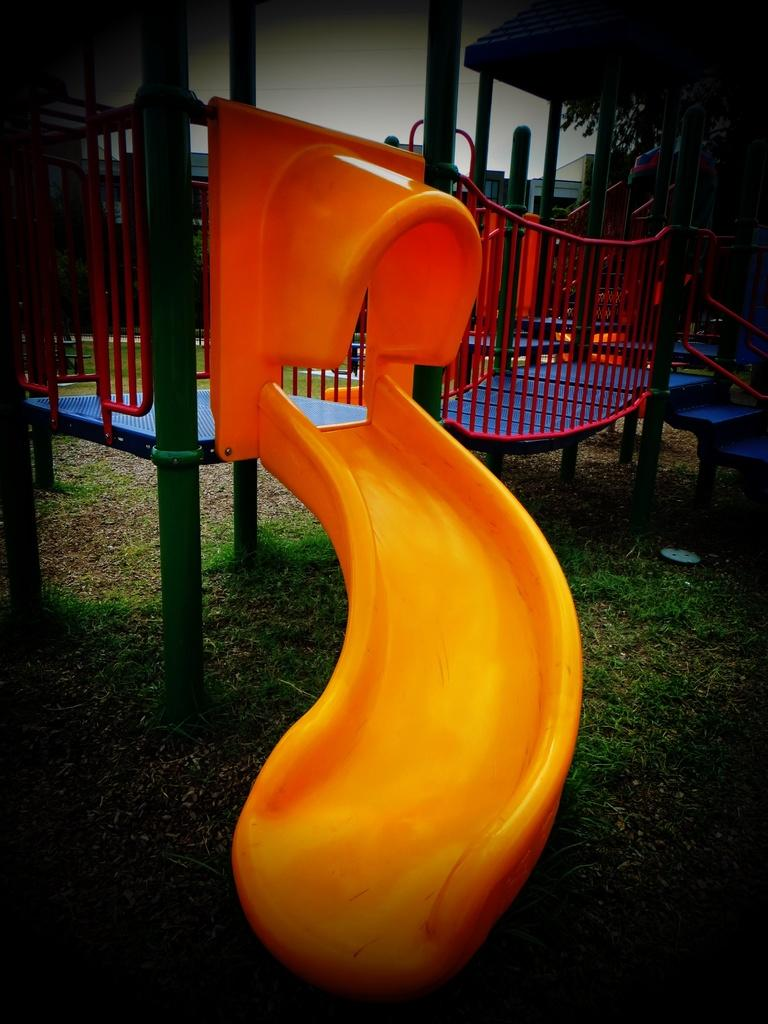What is the main object in the image? There is a garden slide in the image. What color is the garden slide? The garden slide is yellow in color. What can be seen in the background of the image? The sky is visible in the background of the image, along with other objects. How does the beginner use the garden slide in the image? There is no indication of a beginner or their actions in the image, as it only shows a yellow garden slide. 